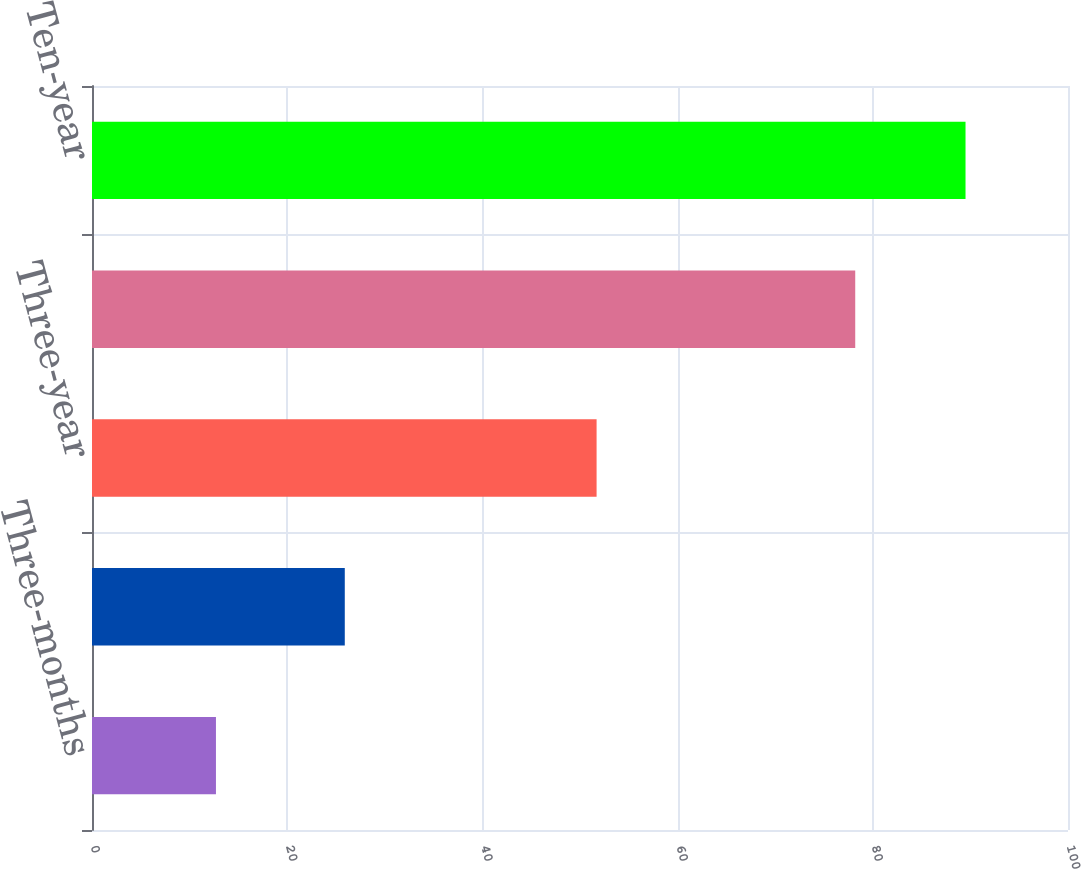Convert chart to OTSL. <chart><loc_0><loc_0><loc_500><loc_500><bar_chart><fcel>Three-months<fcel>One-year<fcel>Three-year<fcel>Five-year<fcel>Ten-year<nl><fcel>12.7<fcel>25.9<fcel>51.7<fcel>78.2<fcel>89.5<nl></chart> 